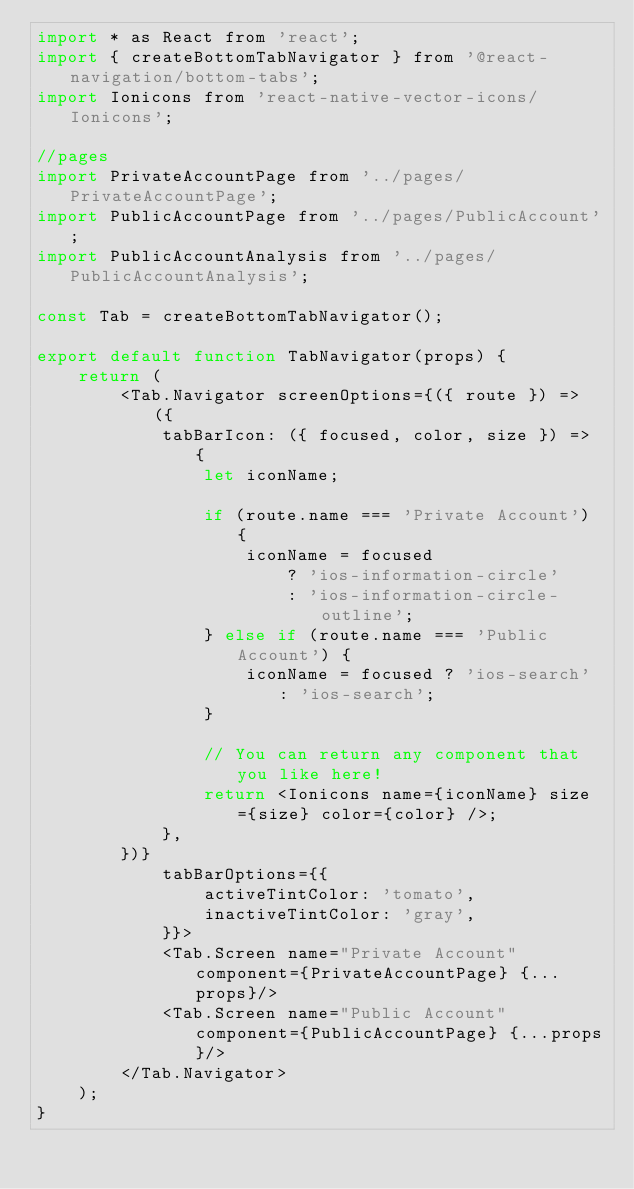Convert code to text. <code><loc_0><loc_0><loc_500><loc_500><_JavaScript_>import * as React from 'react';
import { createBottomTabNavigator } from '@react-navigation/bottom-tabs';
import Ionicons from 'react-native-vector-icons/Ionicons';

//pages
import PrivateAccountPage from '../pages/PrivateAccountPage';
import PublicAccountPage from '../pages/PublicAccount';
import PublicAccountAnalysis from '../pages/PublicAccountAnalysis';

const Tab = createBottomTabNavigator();

export default function TabNavigator(props) {
    return (
        <Tab.Navigator screenOptions={({ route }) => ({
            tabBarIcon: ({ focused, color, size }) => {
                let iconName;

                if (route.name === 'Private Account') {
                    iconName = focused
                        ? 'ios-information-circle'
                        : 'ios-information-circle-outline';
                } else if (route.name === 'Public Account') {
                    iconName = focused ? 'ios-search' : 'ios-search';
                }

                // You can return any component that you like here!
                return <Ionicons name={iconName} size={size} color={color} />;
            },
        })}
            tabBarOptions={{
                activeTintColor: 'tomato',
                inactiveTintColor: 'gray',
            }}>
            <Tab.Screen name="Private Account" component={PrivateAccountPage} {...props}/>
            <Tab.Screen name="Public Account" component={PublicAccountPage} {...props}/>
        </Tab.Navigator>
    );
}</code> 